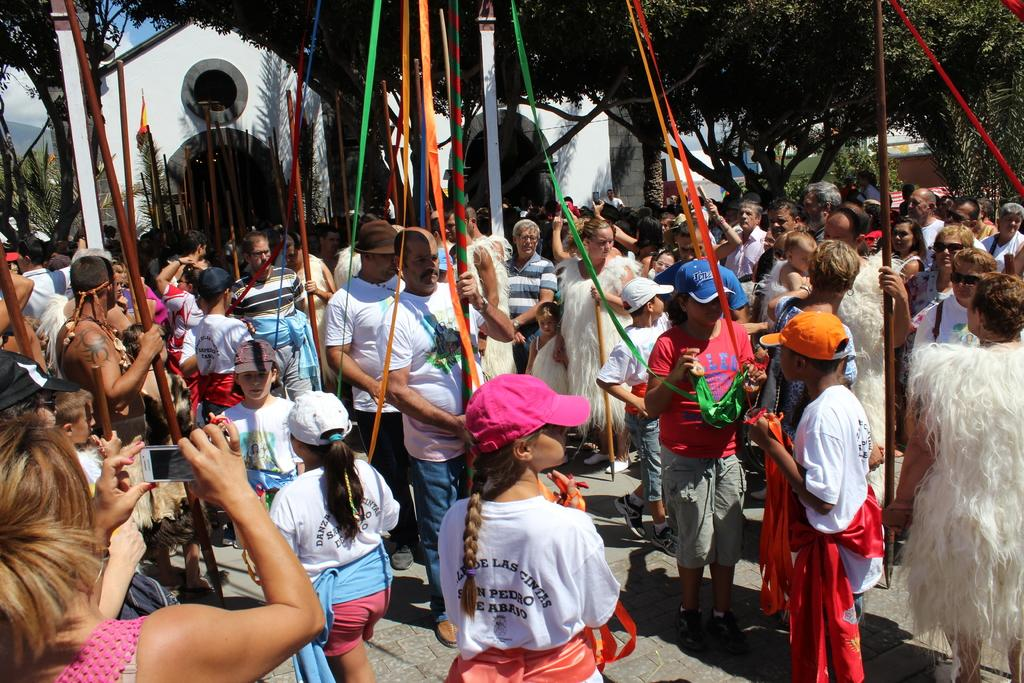How many people are in the image? There is a group of people in the image. What are the people holding in their hands? The people are holding sticks in their hands. Can you describe the actions of one person in the image? One person is holding a mobile with her hands. What can be seen in the background of the image? There are trees, a building, and the sky visible in the background of the image. What type of notebook is the writer using in the image? There is no writer or notebook present in the image. 